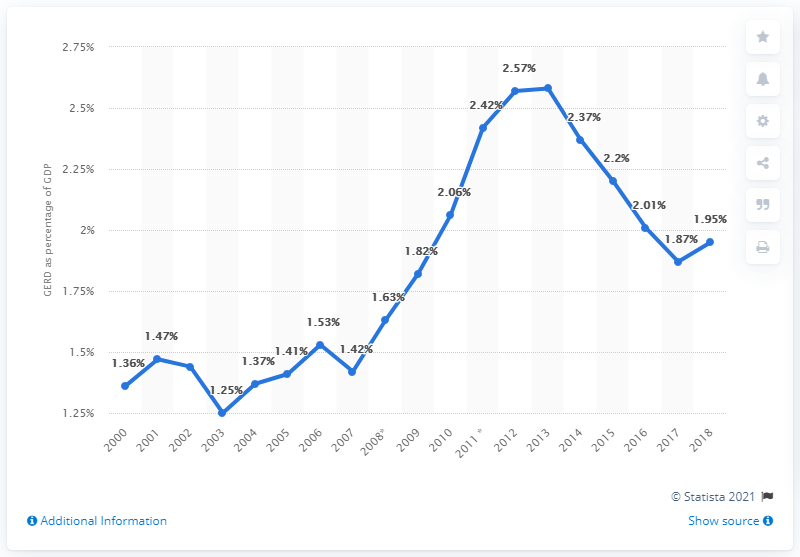Highlight a few significant elements in this photo. In 2018, the net increase of the Gross Domestic Product (GERD) to Gross Domestic Product (GDP) in Slovenia was 1.95%. 